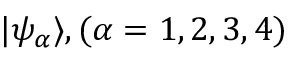<formula> <loc_0><loc_0><loc_500><loc_500>| \psi _ { \alpha } \rangle , ( \alpha = 1 , 2 , 3 , 4 )</formula> 